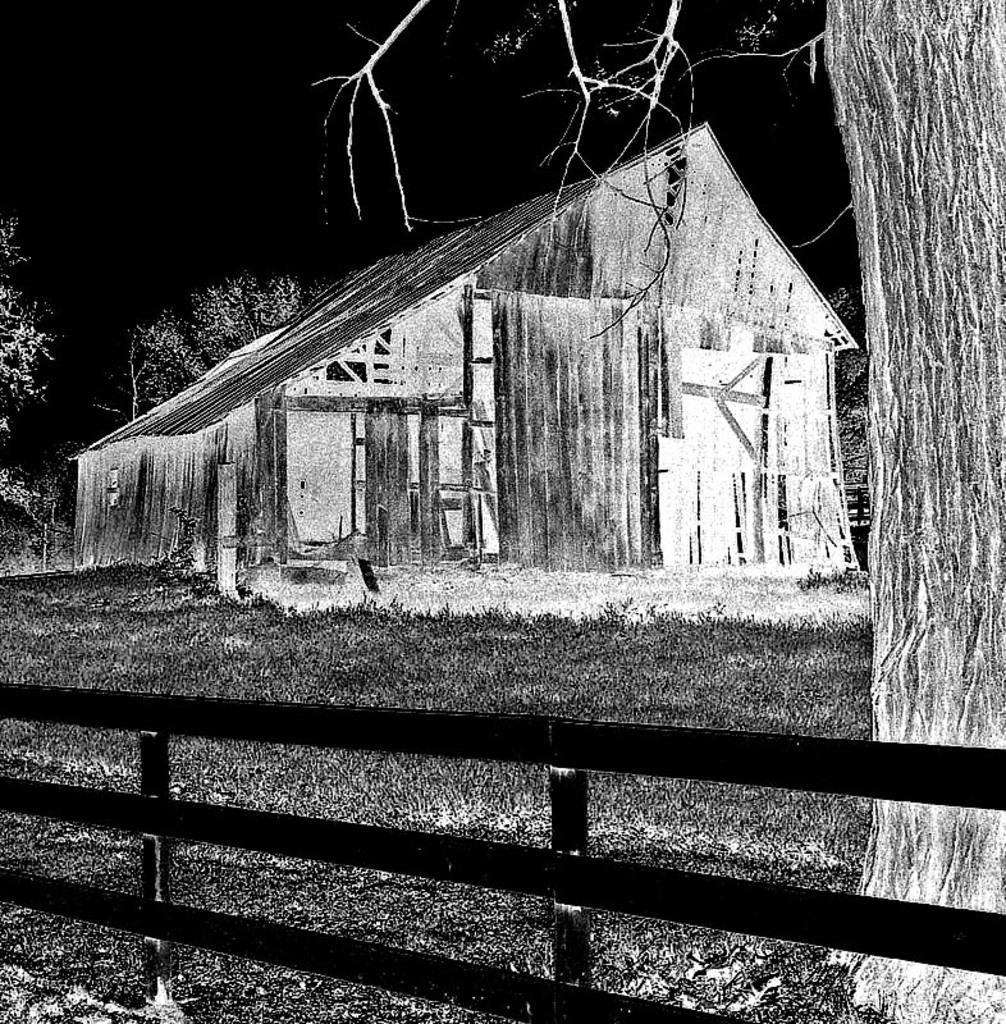Please provide a concise description of this image. This is an edited image. We can see a fence at the bottom of this image and there is a grassy land behind this fence. We can see a house and trees in the middle of this image. It is dark at the top of this image. 